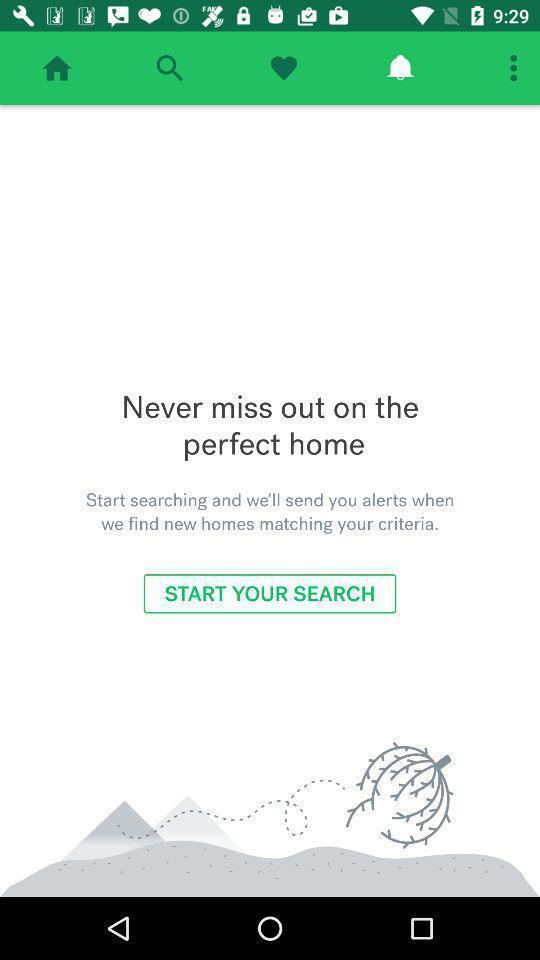What can you discern from this picture? Screen displaying contents in alert page. 